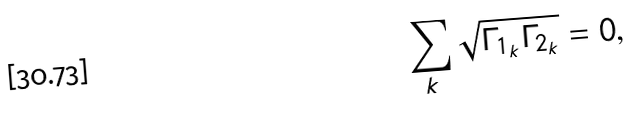<formula> <loc_0><loc_0><loc_500><loc_500>\sum _ { k } \sqrt { \Gamma _ { 1 _ { k } } \Gamma _ { 2 _ { k } } } = 0 ,</formula> 